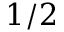<formula> <loc_0><loc_0><loc_500><loc_500>1 / 2</formula> 